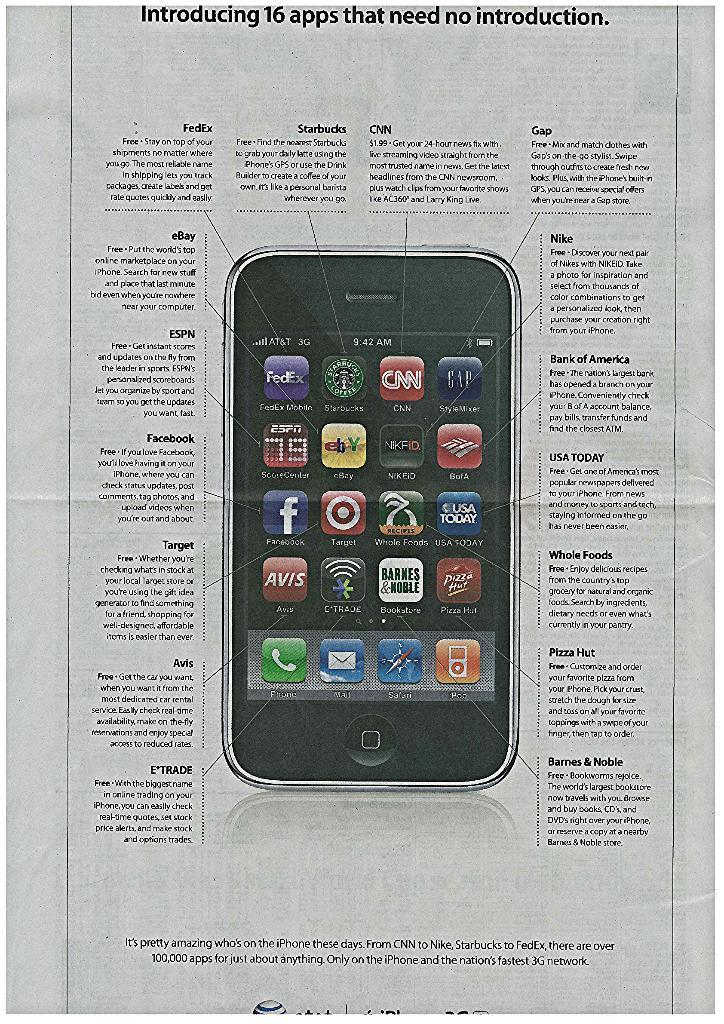<image>
Give a short and clear explanation of the subsequent image. the instruction page for an apple branded phone with icons for facebook and cnn. 